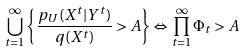Convert formula to latex. <formula><loc_0><loc_0><loc_500><loc_500>\bigcup _ { t = 1 } ^ { \infty } \left \{ \frac { p _ { U } ( X ^ { t } | Y ^ { t } ) } { q ( X ^ { t } ) } > A \right \} \Leftrightarrow \prod _ { t = 1 } ^ { \infty } \Phi _ { t } > A</formula> 